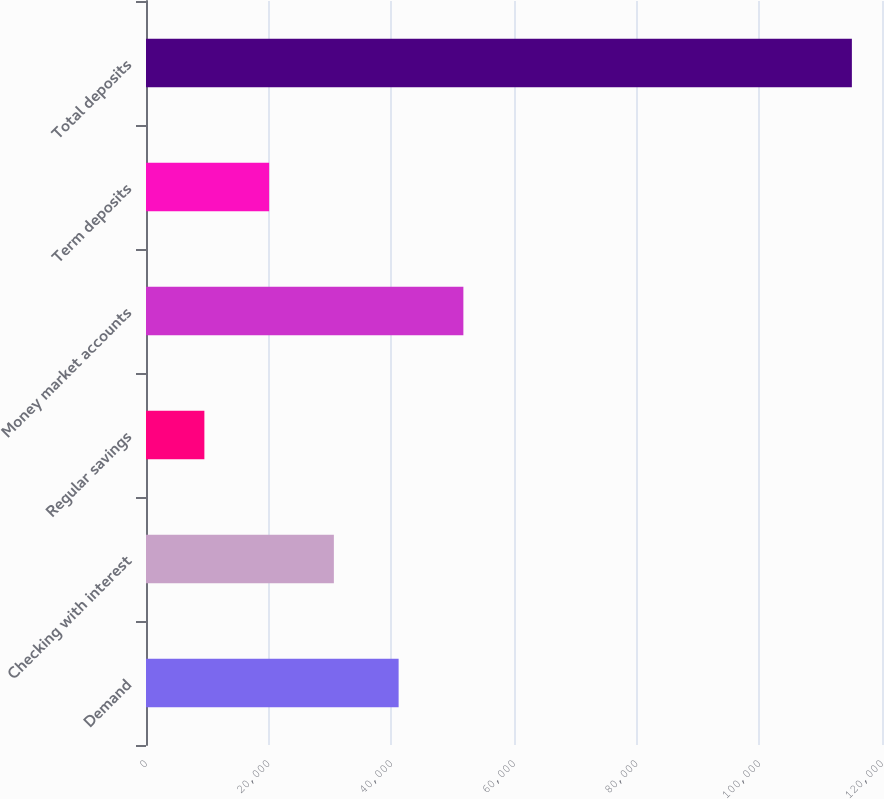Convert chart. <chart><loc_0><loc_0><loc_500><loc_500><bar_chart><fcel>Demand<fcel>Checking with interest<fcel>Regular savings<fcel>Money market accounts<fcel>Term deposits<fcel>Total deposits<nl><fcel>41189.3<fcel>30632.2<fcel>9518<fcel>51746.4<fcel>20075.1<fcel>115089<nl></chart> 